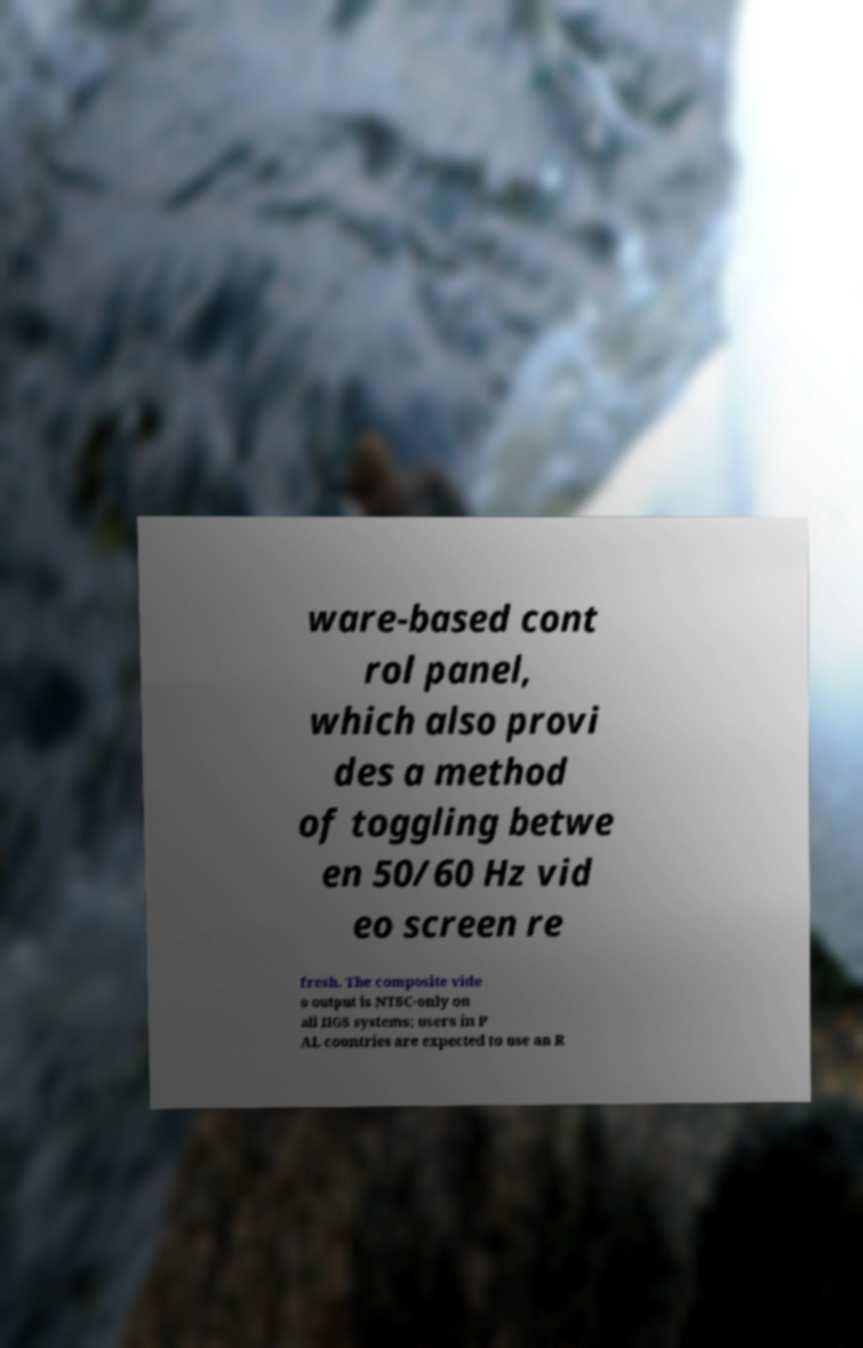What messages or text are displayed in this image? I need them in a readable, typed format. ware-based cont rol panel, which also provi des a method of toggling betwe en 50/60 Hz vid eo screen re fresh. The composite vide o output is NTSC-only on all IIGS systems; users in P AL countries are expected to use an R 